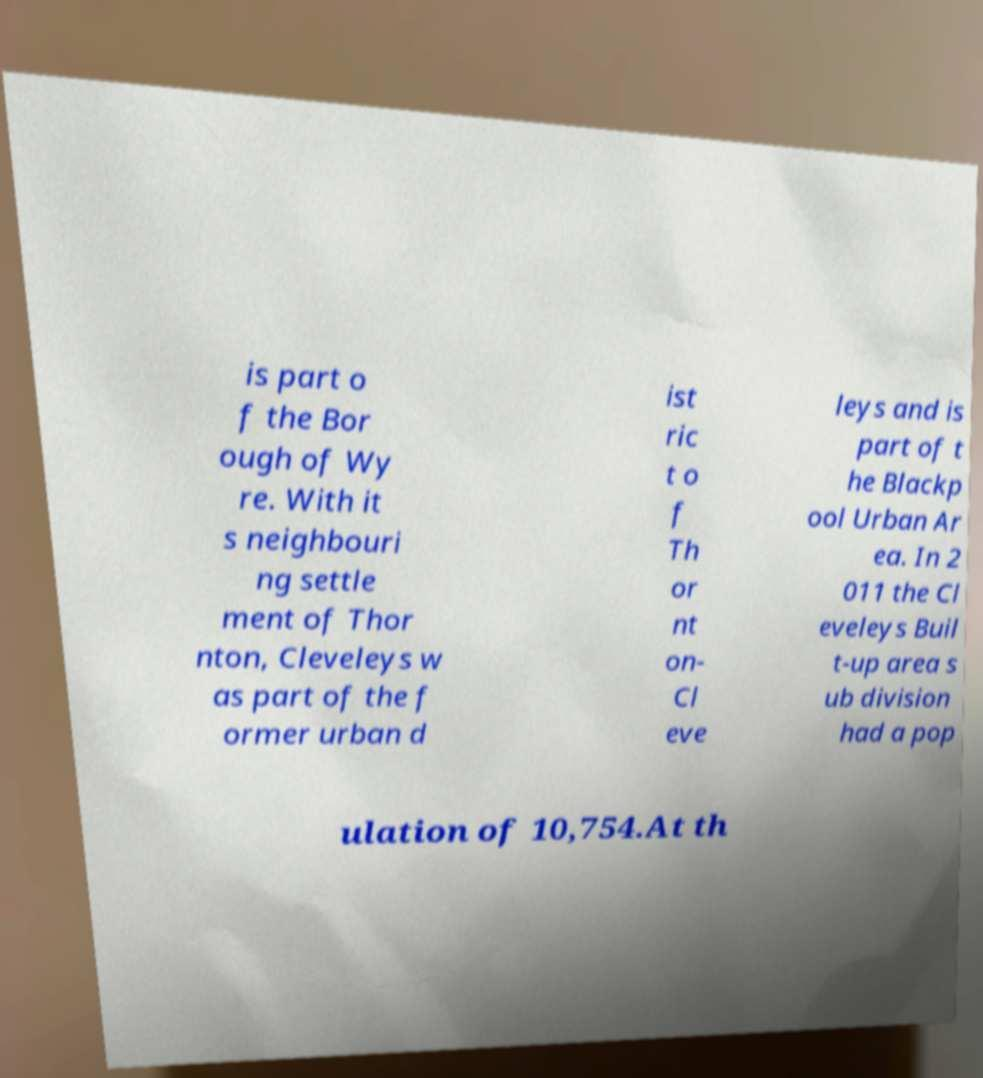There's text embedded in this image that I need extracted. Can you transcribe it verbatim? is part o f the Bor ough of Wy re. With it s neighbouri ng settle ment of Thor nton, Cleveleys w as part of the f ormer urban d ist ric t o f Th or nt on- Cl eve leys and is part of t he Blackp ool Urban Ar ea. In 2 011 the Cl eveleys Buil t-up area s ub division had a pop ulation of 10,754.At th 